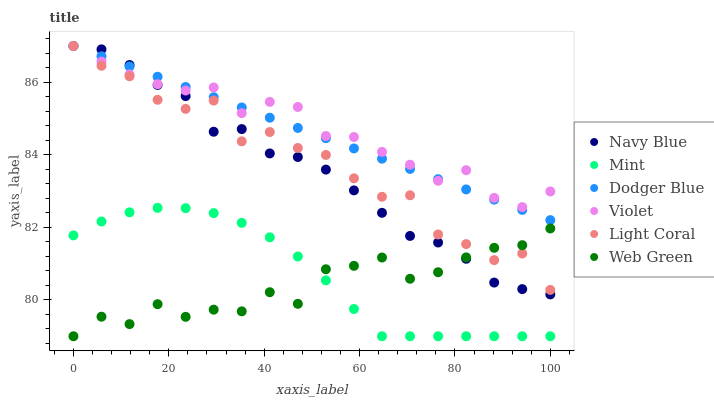Does Web Green have the minimum area under the curve?
Answer yes or no. Yes. Does Violet have the maximum area under the curve?
Answer yes or no. Yes. Does Light Coral have the minimum area under the curve?
Answer yes or no. No. Does Light Coral have the maximum area under the curve?
Answer yes or no. No. Is Dodger Blue the smoothest?
Answer yes or no. Yes. Is Light Coral the roughest?
Answer yes or no. Yes. Is Web Green the smoothest?
Answer yes or no. No. Is Web Green the roughest?
Answer yes or no. No. Does Web Green have the lowest value?
Answer yes or no. Yes. Does Light Coral have the lowest value?
Answer yes or no. No. Does Violet have the highest value?
Answer yes or no. Yes. Does Web Green have the highest value?
Answer yes or no. No. Is Mint less than Light Coral?
Answer yes or no. Yes. Is Navy Blue greater than Mint?
Answer yes or no. Yes. Does Dodger Blue intersect Violet?
Answer yes or no. Yes. Is Dodger Blue less than Violet?
Answer yes or no. No. Is Dodger Blue greater than Violet?
Answer yes or no. No. Does Mint intersect Light Coral?
Answer yes or no. No. 